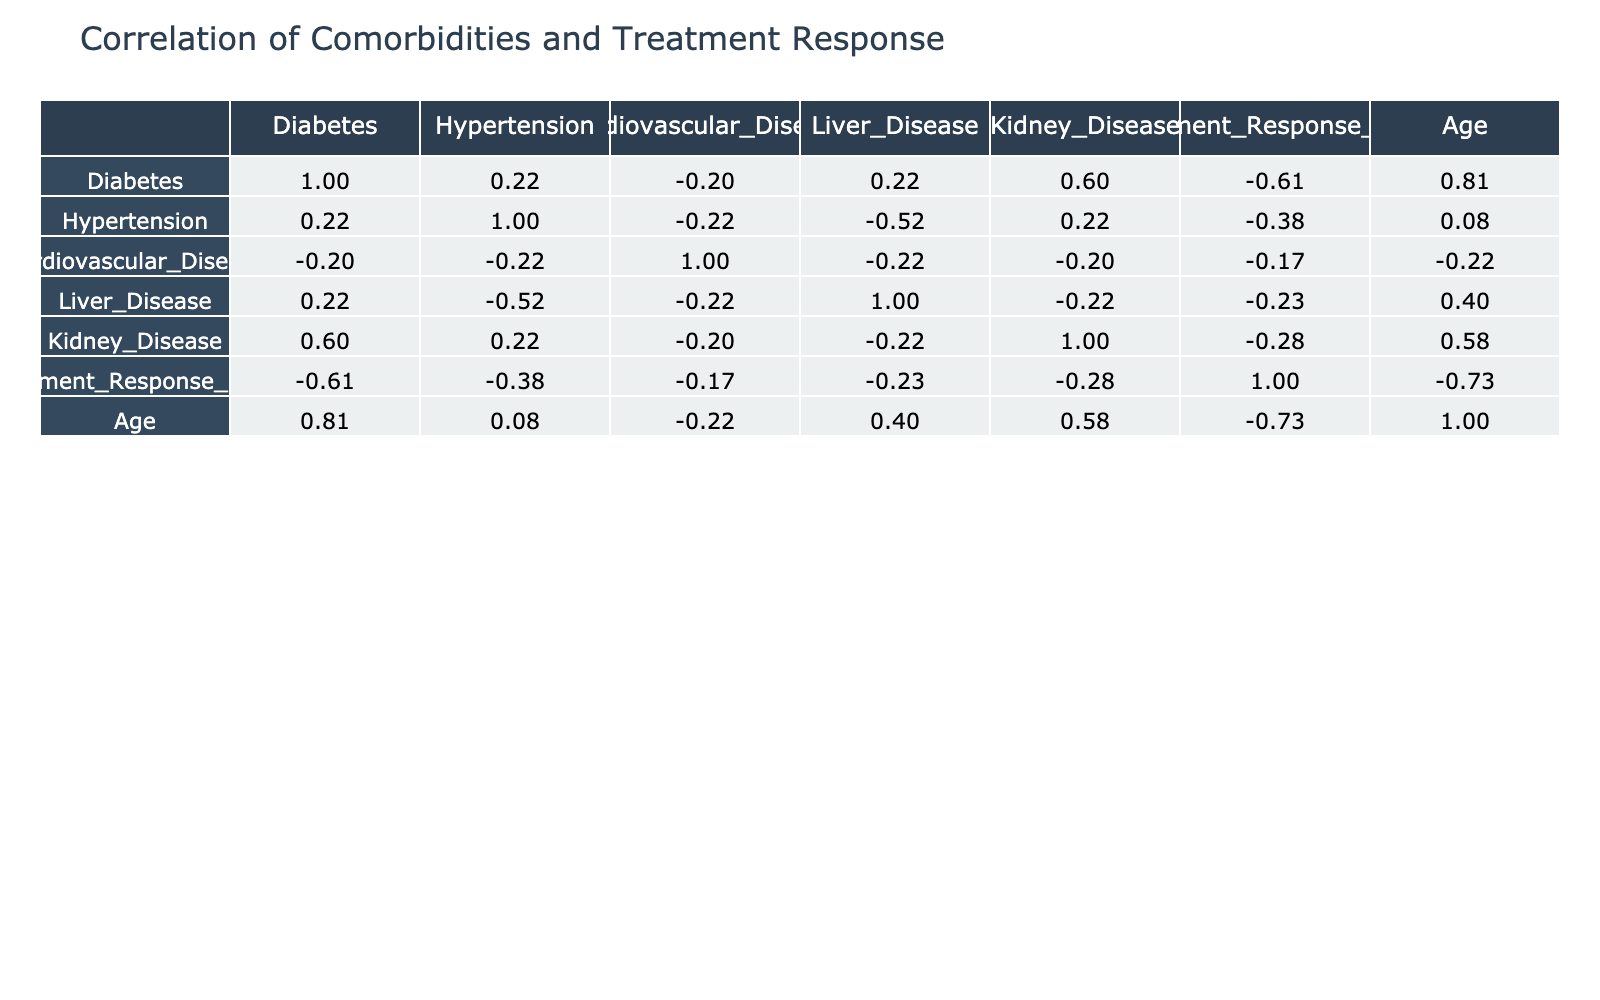What is the correlation between diabetes and treatment response score? Looking at the correlation matrix, the correlation coefficient between diabetes and treatment response score is -0.45, which indicates a moderate negative correlation. This suggests that higher rates of diabetes may be associated with lower treatment response scores among the patients.
Answer: -0.45 How many patients have both hypertension and liver disease? By examining the table, we can see that patient ID 5 has both hypertension and liver disease. Thus, there is only 1 patient with these two comorbidities.
Answer: 1 Is there a significant correlation between age and treatment response score? The correlation coefficient between age and treatment response score is -0.56, which indicates a moderate to strong negative correlation. This means that as age increases, the treatment response score tends to decrease.
Answer: -0.56 What is the average treatment response score for patients with cardiovascular disease? From the data, the treatment response scores for patients with cardiovascular disease are 5 (patient 2), 4 (patient 3), and 2 (patient 7). We sum them: 5 + 4 + 2 = 11, and divide by the number of patients (3), hence the average is 11 / 3 ≈ 3.67.
Answer: 3.67 Do patients with kidney disease show a better treatment response compared to those without kidney disease? The average treatment response score for patients with kidney disease includes scores 7 (patient 1), 6 (patient 4), and 5 (patient 9), totaling 18, giving an average of 18 / 3 = 6. For those without kidney disease (scores 5, 6, 3, and 8 from patients 2, 5, 6, and 10), we have an average of 5 + 6 + 3 + 8 = 22, which is 22 / 4 = 5.5. Therefore, the average score for patients with kidney disease is higher at 6 compared to 5.5 for those without.
Answer: Yes What is the correlation between liver disease and age? The correlation coefficient for liver disease and age is 0.32. This indicates a weak positive correlation, suggesting that older age may be slightly associated with the presence of liver disease among the patients studied.
Answer: 0.32 